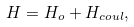<formula> <loc_0><loc_0><loc_500><loc_500>H = H _ { o } + H _ { c o u l } ,</formula> 